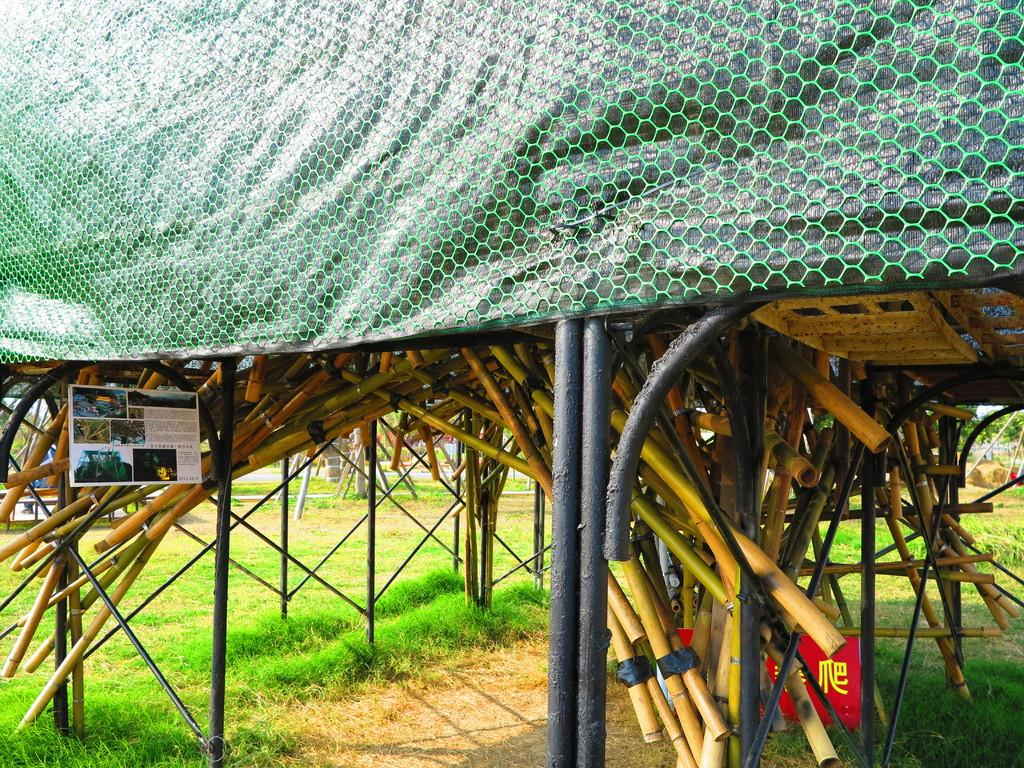What type of vegetation is present on the land in the image? There is grass on the land in the image. What structure is situated above the grass in the image? There is a tent above the grass in the image. What can be seen mounted inside the tent in the image? Bamboo sticks are mounted in the tent in the image. What type of winter activity is happening inside the tent in the image? There is no indication of any winter activity happening inside the tent in the image. How many bees can be seen buzzing around the bamboo sticks in the image? There are no bees present in the image. 